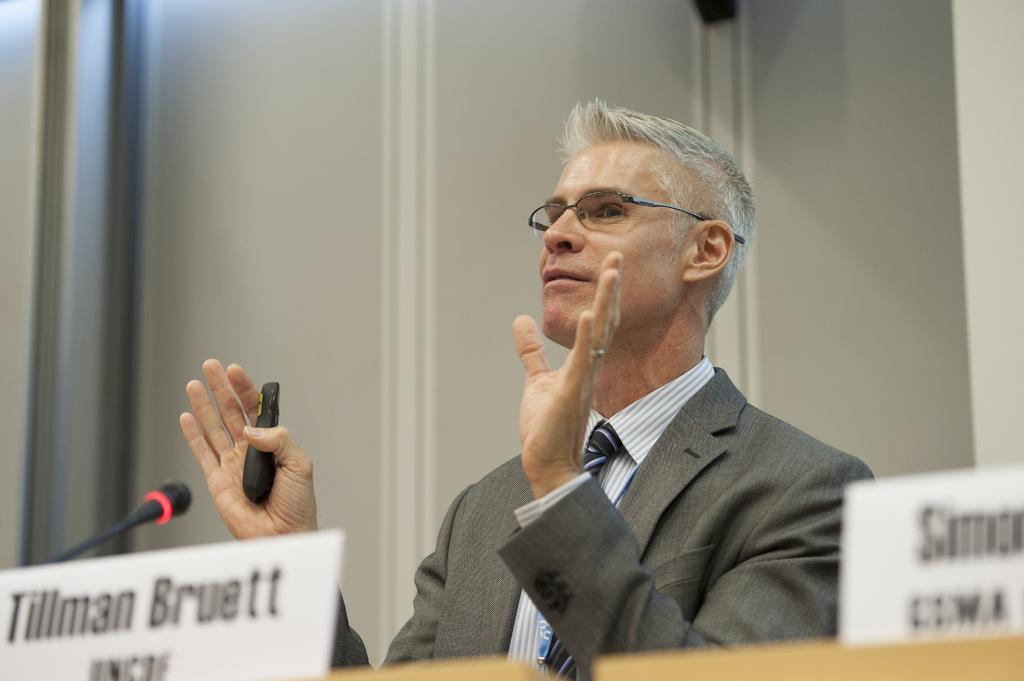What is the person in the image doing? The person is standing in the image. What is the person wearing? The person is wearing a suit. What is the person holding in his hand? The person is holding an object in his hand. What objects are present in the image related to communication? There are name stands and a microphone in the image. What type of haircut does the person have in the image? There is no information about the person's haircut in the image. Can you see any patches on the person's suit? There is no mention of patches on the person's suit in the image. 